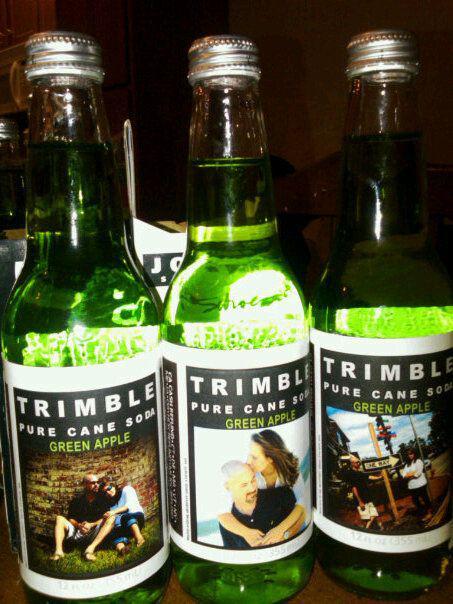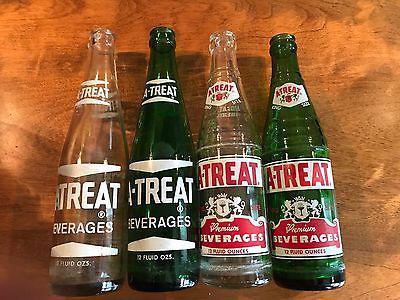The first image is the image on the left, the second image is the image on the right. For the images displayed, is the sentence "There are exactly seven bottles in total." factually correct? Answer yes or no. Yes. The first image is the image on the left, the second image is the image on the right. Evaluate the accuracy of this statement regarding the images: "There are seven bottles in total.". Is it true? Answer yes or no. Yes. 